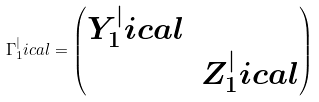Convert formula to latex. <formula><loc_0><loc_0><loc_500><loc_500>\Gamma _ { 1 } ^ { | } i c a l = \left ( \begin{matrix} Y _ { 1 } ^ { | } i c a l & \\ & Z _ { 1 } ^ { | } i c a l \end{matrix} \right )</formula> 